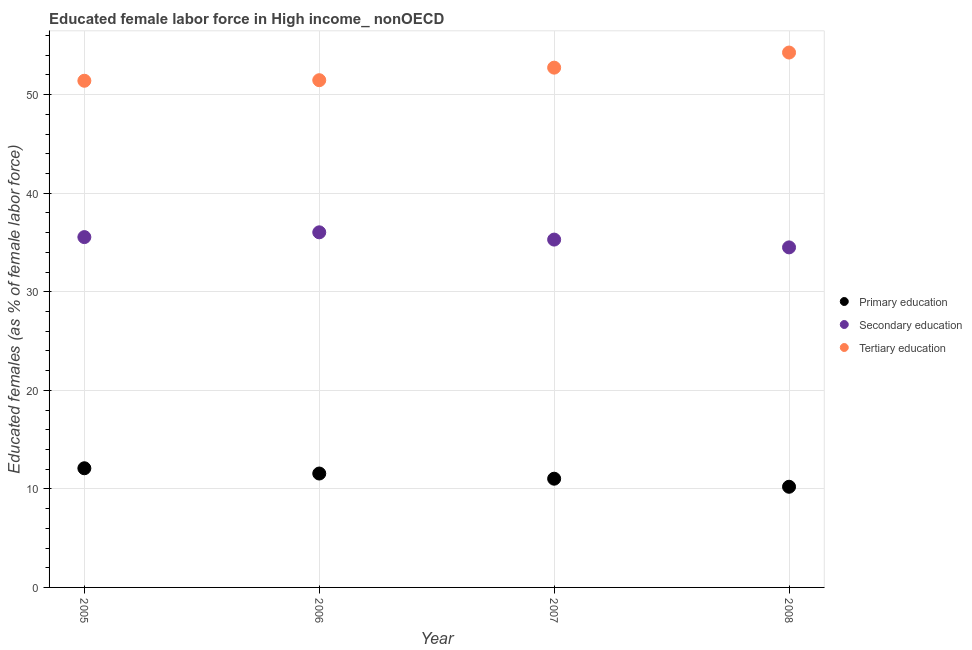What is the percentage of female labor force who received primary education in 2006?
Provide a succinct answer. 11.56. Across all years, what is the maximum percentage of female labor force who received secondary education?
Keep it short and to the point. 36.03. Across all years, what is the minimum percentage of female labor force who received primary education?
Your response must be concise. 10.21. What is the total percentage of female labor force who received tertiary education in the graph?
Make the answer very short. 209.9. What is the difference between the percentage of female labor force who received secondary education in 2005 and that in 2008?
Provide a short and direct response. 1.04. What is the difference between the percentage of female labor force who received secondary education in 2008 and the percentage of female labor force who received tertiary education in 2005?
Your answer should be very brief. -16.91. What is the average percentage of female labor force who received tertiary education per year?
Your answer should be very brief. 52.48. In the year 2006, what is the difference between the percentage of female labor force who received primary education and percentage of female labor force who received secondary education?
Your answer should be compact. -24.48. What is the ratio of the percentage of female labor force who received tertiary education in 2005 to that in 2006?
Offer a terse response. 1. Is the percentage of female labor force who received secondary education in 2006 less than that in 2008?
Keep it short and to the point. No. Is the difference between the percentage of female labor force who received secondary education in 2006 and 2007 greater than the difference between the percentage of female labor force who received tertiary education in 2006 and 2007?
Your answer should be compact. Yes. What is the difference between the highest and the second highest percentage of female labor force who received tertiary education?
Ensure brevity in your answer.  1.53. What is the difference between the highest and the lowest percentage of female labor force who received primary education?
Your response must be concise. 1.88. Is the sum of the percentage of female labor force who received secondary education in 2006 and 2008 greater than the maximum percentage of female labor force who received primary education across all years?
Keep it short and to the point. Yes. Is the percentage of female labor force who received secondary education strictly greater than the percentage of female labor force who received tertiary education over the years?
Provide a succinct answer. No. How many years are there in the graph?
Provide a short and direct response. 4. What is the difference between two consecutive major ticks on the Y-axis?
Your answer should be very brief. 10. Are the values on the major ticks of Y-axis written in scientific E-notation?
Provide a succinct answer. No. How many legend labels are there?
Offer a terse response. 3. What is the title of the graph?
Offer a very short reply. Educated female labor force in High income_ nonOECD. Does "Secondary" appear as one of the legend labels in the graph?
Give a very brief answer. No. What is the label or title of the Y-axis?
Provide a short and direct response. Educated females (as % of female labor force). What is the Educated females (as % of female labor force) of Primary education in 2005?
Your answer should be very brief. 12.09. What is the Educated females (as % of female labor force) in Secondary education in 2005?
Offer a very short reply. 35.55. What is the Educated females (as % of female labor force) in Tertiary education in 2005?
Ensure brevity in your answer.  51.41. What is the Educated females (as % of female labor force) in Primary education in 2006?
Your answer should be very brief. 11.56. What is the Educated females (as % of female labor force) of Secondary education in 2006?
Your response must be concise. 36.03. What is the Educated females (as % of female labor force) in Tertiary education in 2006?
Ensure brevity in your answer.  51.47. What is the Educated females (as % of female labor force) in Primary education in 2007?
Ensure brevity in your answer.  11.03. What is the Educated females (as % of female labor force) in Secondary education in 2007?
Your answer should be compact. 35.3. What is the Educated females (as % of female labor force) of Tertiary education in 2007?
Your answer should be very brief. 52.74. What is the Educated females (as % of female labor force) in Primary education in 2008?
Ensure brevity in your answer.  10.21. What is the Educated females (as % of female labor force) of Secondary education in 2008?
Your response must be concise. 34.51. What is the Educated females (as % of female labor force) in Tertiary education in 2008?
Give a very brief answer. 54.28. Across all years, what is the maximum Educated females (as % of female labor force) in Primary education?
Your answer should be very brief. 12.09. Across all years, what is the maximum Educated females (as % of female labor force) in Secondary education?
Your response must be concise. 36.03. Across all years, what is the maximum Educated females (as % of female labor force) of Tertiary education?
Your answer should be compact. 54.28. Across all years, what is the minimum Educated females (as % of female labor force) of Primary education?
Offer a very short reply. 10.21. Across all years, what is the minimum Educated females (as % of female labor force) of Secondary education?
Offer a terse response. 34.51. Across all years, what is the minimum Educated females (as % of female labor force) in Tertiary education?
Ensure brevity in your answer.  51.41. What is the total Educated females (as % of female labor force) of Primary education in the graph?
Give a very brief answer. 44.9. What is the total Educated females (as % of female labor force) of Secondary education in the graph?
Your answer should be very brief. 141.38. What is the total Educated females (as % of female labor force) in Tertiary education in the graph?
Your answer should be compact. 209.9. What is the difference between the Educated females (as % of female labor force) of Primary education in 2005 and that in 2006?
Ensure brevity in your answer.  0.53. What is the difference between the Educated females (as % of female labor force) in Secondary education in 2005 and that in 2006?
Give a very brief answer. -0.49. What is the difference between the Educated females (as % of female labor force) of Tertiary education in 2005 and that in 2006?
Your response must be concise. -0.06. What is the difference between the Educated females (as % of female labor force) of Primary education in 2005 and that in 2007?
Offer a terse response. 1.06. What is the difference between the Educated females (as % of female labor force) of Secondary education in 2005 and that in 2007?
Offer a very short reply. 0.25. What is the difference between the Educated females (as % of female labor force) of Tertiary education in 2005 and that in 2007?
Keep it short and to the point. -1.33. What is the difference between the Educated females (as % of female labor force) of Primary education in 2005 and that in 2008?
Offer a very short reply. 1.88. What is the difference between the Educated females (as % of female labor force) in Secondary education in 2005 and that in 2008?
Give a very brief answer. 1.04. What is the difference between the Educated females (as % of female labor force) in Tertiary education in 2005 and that in 2008?
Make the answer very short. -2.86. What is the difference between the Educated females (as % of female labor force) in Primary education in 2006 and that in 2007?
Provide a short and direct response. 0.53. What is the difference between the Educated females (as % of female labor force) in Secondary education in 2006 and that in 2007?
Your answer should be compact. 0.74. What is the difference between the Educated females (as % of female labor force) of Tertiary education in 2006 and that in 2007?
Keep it short and to the point. -1.27. What is the difference between the Educated females (as % of female labor force) of Primary education in 2006 and that in 2008?
Keep it short and to the point. 1.34. What is the difference between the Educated females (as % of female labor force) in Secondary education in 2006 and that in 2008?
Provide a succinct answer. 1.53. What is the difference between the Educated females (as % of female labor force) of Tertiary education in 2006 and that in 2008?
Keep it short and to the point. -2.81. What is the difference between the Educated females (as % of female labor force) in Primary education in 2007 and that in 2008?
Offer a terse response. 0.82. What is the difference between the Educated females (as % of female labor force) of Secondary education in 2007 and that in 2008?
Give a very brief answer. 0.79. What is the difference between the Educated females (as % of female labor force) of Tertiary education in 2007 and that in 2008?
Offer a terse response. -1.53. What is the difference between the Educated females (as % of female labor force) in Primary education in 2005 and the Educated females (as % of female labor force) in Secondary education in 2006?
Your answer should be very brief. -23.94. What is the difference between the Educated females (as % of female labor force) in Primary education in 2005 and the Educated females (as % of female labor force) in Tertiary education in 2006?
Offer a very short reply. -39.38. What is the difference between the Educated females (as % of female labor force) of Secondary education in 2005 and the Educated females (as % of female labor force) of Tertiary education in 2006?
Keep it short and to the point. -15.92. What is the difference between the Educated females (as % of female labor force) of Primary education in 2005 and the Educated females (as % of female labor force) of Secondary education in 2007?
Your answer should be very brief. -23.2. What is the difference between the Educated females (as % of female labor force) of Primary education in 2005 and the Educated females (as % of female labor force) of Tertiary education in 2007?
Your answer should be very brief. -40.65. What is the difference between the Educated females (as % of female labor force) in Secondary education in 2005 and the Educated females (as % of female labor force) in Tertiary education in 2007?
Keep it short and to the point. -17.2. What is the difference between the Educated females (as % of female labor force) of Primary education in 2005 and the Educated females (as % of female labor force) of Secondary education in 2008?
Your response must be concise. -22.41. What is the difference between the Educated females (as % of female labor force) in Primary education in 2005 and the Educated females (as % of female labor force) in Tertiary education in 2008?
Your response must be concise. -42.18. What is the difference between the Educated females (as % of female labor force) in Secondary education in 2005 and the Educated females (as % of female labor force) in Tertiary education in 2008?
Offer a terse response. -18.73. What is the difference between the Educated females (as % of female labor force) in Primary education in 2006 and the Educated females (as % of female labor force) in Secondary education in 2007?
Your answer should be compact. -23.74. What is the difference between the Educated females (as % of female labor force) in Primary education in 2006 and the Educated females (as % of female labor force) in Tertiary education in 2007?
Make the answer very short. -41.19. What is the difference between the Educated females (as % of female labor force) in Secondary education in 2006 and the Educated females (as % of female labor force) in Tertiary education in 2007?
Keep it short and to the point. -16.71. What is the difference between the Educated females (as % of female labor force) in Primary education in 2006 and the Educated females (as % of female labor force) in Secondary education in 2008?
Keep it short and to the point. -22.95. What is the difference between the Educated females (as % of female labor force) of Primary education in 2006 and the Educated females (as % of female labor force) of Tertiary education in 2008?
Offer a terse response. -42.72. What is the difference between the Educated females (as % of female labor force) in Secondary education in 2006 and the Educated females (as % of female labor force) in Tertiary education in 2008?
Offer a terse response. -18.24. What is the difference between the Educated females (as % of female labor force) of Primary education in 2007 and the Educated females (as % of female labor force) of Secondary education in 2008?
Offer a very short reply. -23.47. What is the difference between the Educated females (as % of female labor force) in Primary education in 2007 and the Educated females (as % of female labor force) in Tertiary education in 2008?
Your answer should be compact. -43.24. What is the difference between the Educated females (as % of female labor force) of Secondary education in 2007 and the Educated females (as % of female labor force) of Tertiary education in 2008?
Your response must be concise. -18.98. What is the average Educated females (as % of female labor force) in Primary education per year?
Give a very brief answer. 11.22. What is the average Educated females (as % of female labor force) of Secondary education per year?
Your answer should be very brief. 35.35. What is the average Educated females (as % of female labor force) in Tertiary education per year?
Provide a succinct answer. 52.48. In the year 2005, what is the difference between the Educated females (as % of female labor force) in Primary education and Educated females (as % of female labor force) in Secondary education?
Your answer should be very brief. -23.46. In the year 2005, what is the difference between the Educated females (as % of female labor force) of Primary education and Educated females (as % of female labor force) of Tertiary education?
Keep it short and to the point. -39.32. In the year 2005, what is the difference between the Educated females (as % of female labor force) of Secondary education and Educated females (as % of female labor force) of Tertiary education?
Give a very brief answer. -15.87. In the year 2006, what is the difference between the Educated females (as % of female labor force) in Primary education and Educated females (as % of female labor force) in Secondary education?
Your answer should be very brief. -24.48. In the year 2006, what is the difference between the Educated females (as % of female labor force) in Primary education and Educated females (as % of female labor force) in Tertiary education?
Your response must be concise. -39.91. In the year 2006, what is the difference between the Educated females (as % of female labor force) in Secondary education and Educated females (as % of female labor force) in Tertiary education?
Your answer should be very brief. -15.44. In the year 2007, what is the difference between the Educated females (as % of female labor force) of Primary education and Educated females (as % of female labor force) of Secondary education?
Provide a short and direct response. -24.26. In the year 2007, what is the difference between the Educated females (as % of female labor force) in Primary education and Educated females (as % of female labor force) in Tertiary education?
Your response must be concise. -41.71. In the year 2007, what is the difference between the Educated females (as % of female labor force) of Secondary education and Educated females (as % of female labor force) of Tertiary education?
Provide a succinct answer. -17.45. In the year 2008, what is the difference between the Educated females (as % of female labor force) of Primary education and Educated females (as % of female labor force) of Secondary education?
Keep it short and to the point. -24.29. In the year 2008, what is the difference between the Educated females (as % of female labor force) in Primary education and Educated females (as % of female labor force) in Tertiary education?
Make the answer very short. -44.06. In the year 2008, what is the difference between the Educated females (as % of female labor force) of Secondary education and Educated females (as % of female labor force) of Tertiary education?
Provide a succinct answer. -19.77. What is the ratio of the Educated females (as % of female labor force) in Primary education in 2005 to that in 2006?
Keep it short and to the point. 1.05. What is the ratio of the Educated females (as % of female labor force) of Secondary education in 2005 to that in 2006?
Your answer should be compact. 0.99. What is the ratio of the Educated females (as % of female labor force) of Tertiary education in 2005 to that in 2006?
Make the answer very short. 1. What is the ratio of the Educated females (as % of female labor force) in Primary education in 2005 to that in 2007?
Your answer should be very brief. 1.1. What is the ratio of the Educated females (as % of female labor force) in Tertiary education in 2005 to that in 2007?
Give a very brief answer. 0.97. What is the ratio of the Educated females (as % of female labor force) in Primary education in 2005 to that in 2008?
Your response must be concise. 1.18. What is the ratio of the Educated females (as % of female labor force) in Secondary education in 2005 to that in 2008?
Offer a very short reply. 1.03. What is the ratio of the Educated females (as % of female labor force) of Tertiary education in 2005 to that in 2008?
Keep it short and to the point. 0.95. What is the ratio of the Educated females (as % of female labor force) in Primary education in 2006 to that in 2007?
Offer a very short reply. 1.05. What is the ratio of the Educated females (as % of female labor force) in Secondary education in 2006 to that in 2007?
Keep it short and to the point. 1.02. What is the ratio of the Educated females (as % of female labor force) of Tertiary education in 2006 to that in 2007?
Ensure brevity in your answer.  0.98. What is the ratio of the Educated females (as % of female labor force) in Primary education in 2006 to that in 2008?
Keep it short and to the point. 1.13. What is the ratio of the Educated females (as % of female labor force) of Secondary education in 2006 to that in 2008?
Your response must be concise. 1.04. What is the ratio of the Educated females (as % of female labor force) in Tertiary education in 2006 to that in 2008?
Ensure brevity in your answer.  0.95. What is the ratio of the Educated females (as % of female labor force) of Primary education in 2007 to that in 2008?
Your answer should be very brief. 1.08. What is the ratio of the Educated females (as % of female labor force) in Secondary education in 2007 to that in 2008?
Give a very brief answer. 1.02. What is the ratio of the Educated females (as % of female labor force) in Tertiary education in 2007 to that in 2008?
Give a very brief answer. 0.97. What is the difference between the highest and the second highest Educated females (as % of female labor force) in Primary education?
Your answer should be very brief. 0.53. What is the difference between the highest and the second highest Educated females (as % of female labor force) of Secondary education?
Keep it short and to the point. 0.49. What is the difference between the highest and the second highest Educated females (as % of female labor force) in Tertiary education?
Keep it short and to the point. 1.53. What is the difference between the highest and the lowest Educated females (as % of female labor force) in Primary education?
Offer a very short reply. 1.88. What is the difference between the highest and the lowest Educated females (as % of female labor force) in Secondary education?
Give a very brief answer. 1.53. What is the difference between the highest and the lowest Educated females (as % of female labor force) of Tertiary education?
Provide a short and direct response. 2.86. 